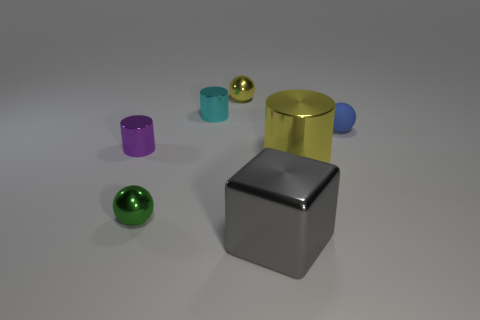There is a sphere that is the same color as the big cylinder; what is its material?
Provide a succinct answer. Metal. Do the large metal cylinder and the shiny ball that is behind the blue rubber object have the same color?
Keep it short and to the point. Yes. How many things are the same color as the big cylinder?
Offer a very short reply. 1. The small blue object has what shape?
Your answer should be compact. Sphere. How many things are either big green shiny cubes or cylinders?
Make the answer very short. 3. Does the metallic object in front of the green shiny sphere have the same size as the yellow metallic object on the right side of the large gray shiny cube?
Provide a short and direct response. Yes. How many other things are made of the same material as the block?
Ensure brevity in your answer.  5. Are there more shiny objects right of the purple cylinder than small blue things that are on the left side of the blue rubber sphere?
Make the answer very short. Yes. There is a small ball to the right of the large gray metallic block; what is its material?
Keep it short and to the point. Rubber. Is the shape of the matte object the same as the tiny green shiny object?
Offer a very short reply. Yes. 